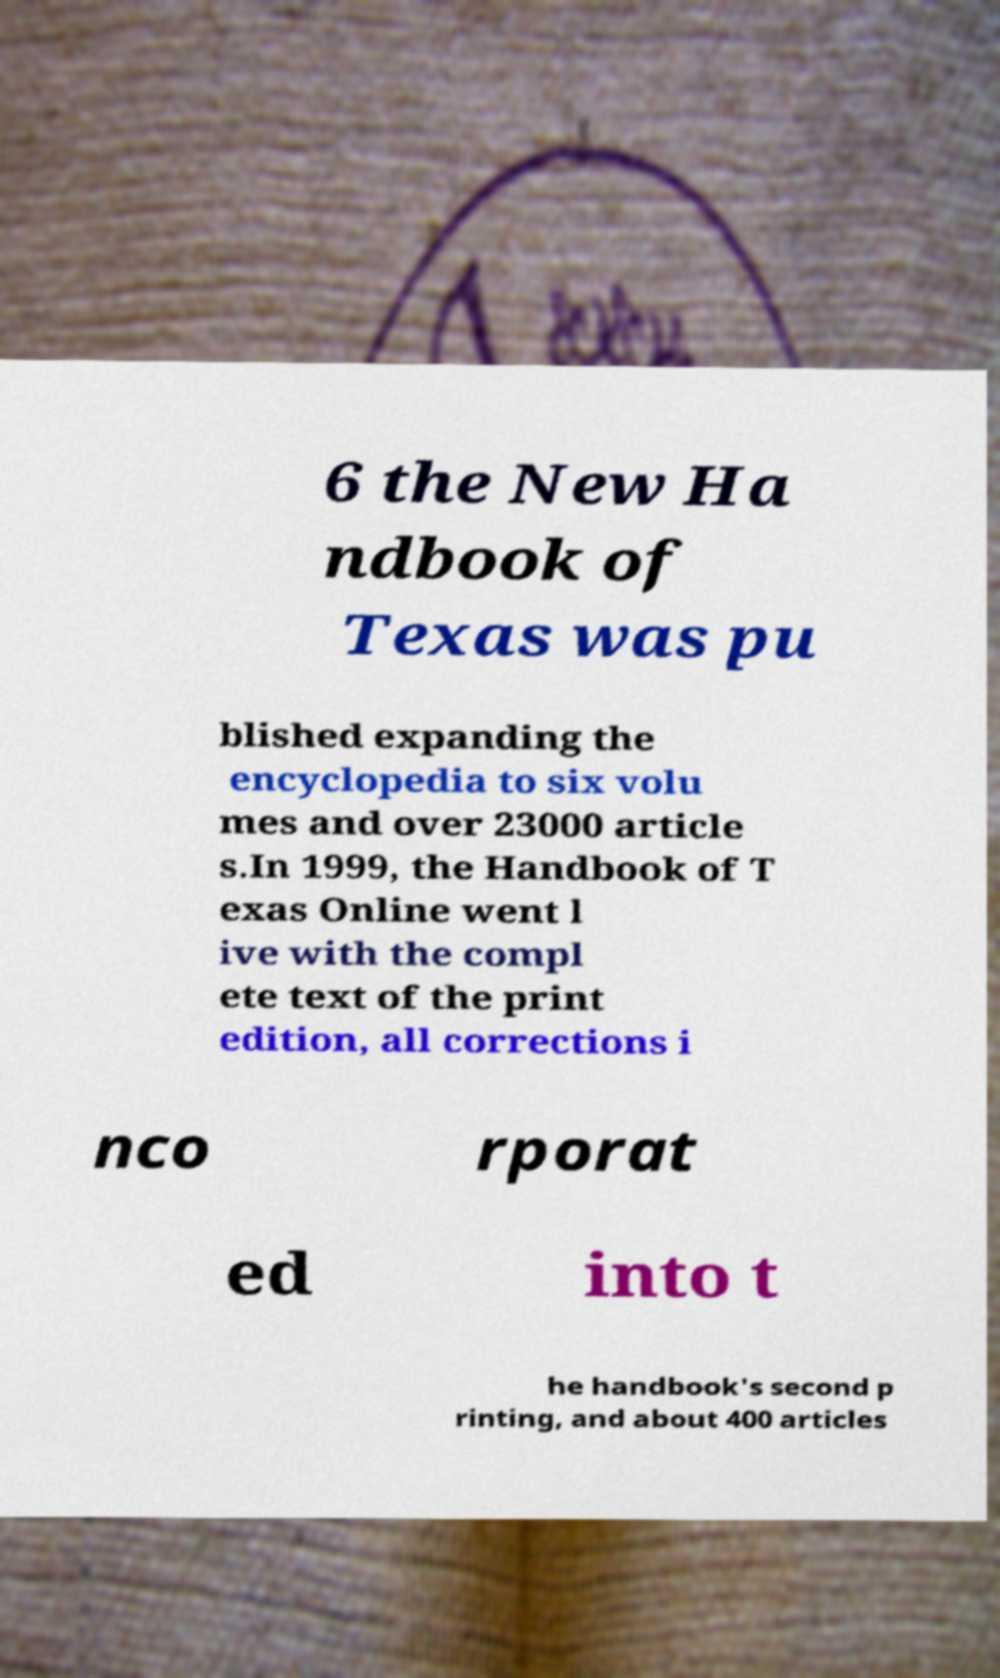What messages or text are displayed in this image? I need them in a readable, typed format. 6 the New Ha ndbook of Texas was pu blished expanding the encyclopedia to six volu mes and over 23000 article s.In 1999, the Handbook of T exas Online went l ive with the compl ete text of the print edition, all corrections i nco rporat ed into t he handbook's second p rinting, and about 400 articles 